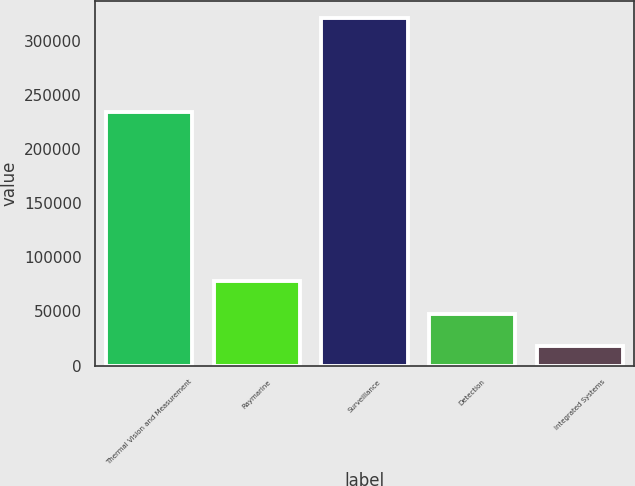<chart> <loc_0><loc_0><loc_500><loc_500><bar_chart><fcel>Thermal Vision and Measurement<fcel>Raymarine<fcel>Surveillance<fcel>Detection<fcel>Integrated Systems<nl><fcel>233888<fcel>78384.6<fcel>320827<fcel>48079.3<fcel>17774<nl></chart> 